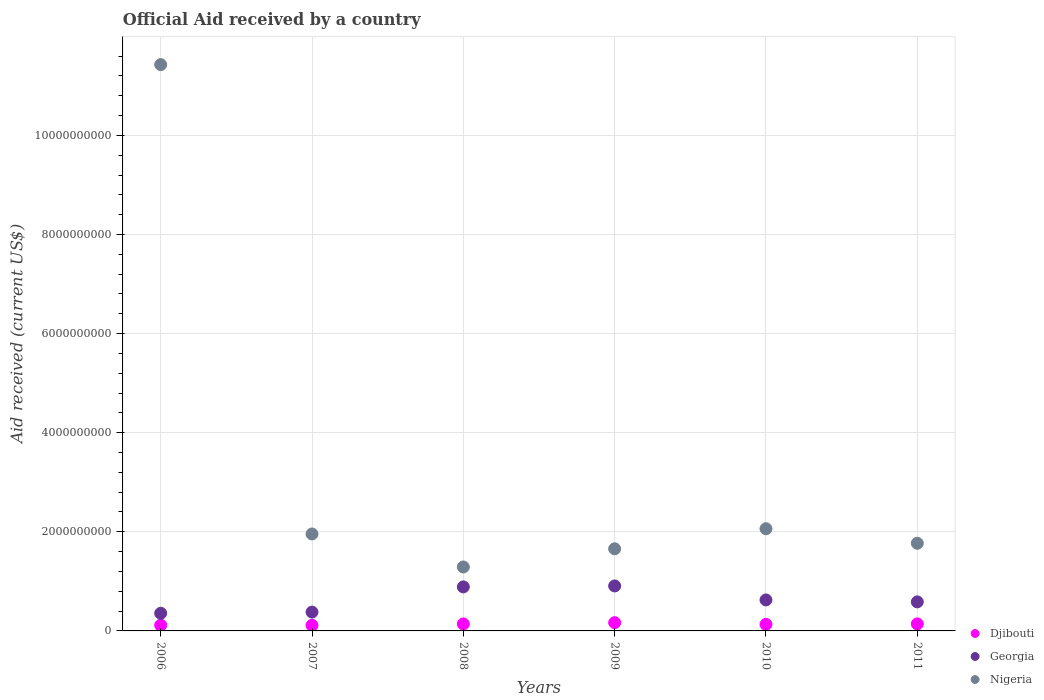How many different coloured dotlines are there?
Offer a terse response. 3. What is the net official aid received in Nigeria in 2008?
Ensure brevity in your answer.  1.29e+09. Across all years, what is the maximum net official aid received in Nigeria?
Offer a very short reply. 1.14e+1. Across all years, what is the minimum net official aid received in Georgia?
Your answer should be very brief. 3.56e+08. In which year was the net official aid received in Nigeria maximum?
Ensure brevity in your answer.  2006. What is the total net official aid received in Djibouti in the graph?
Provide a short and direct response. 8.09e+08. What is the difference between the net official aid received in Djibouti in 2006 and that in 2009?
Offer a terse response. -5.15e+07. What is the difference between the net official aid received in Djibouti in 2008 and the net official aid received in Nigeria in 2009?
Offer a very short reply. -1.52e+09. What is the average net official aid received in Nigeria per year?
Give a very brief answer. 3.36e+09. In the year 2008, what is the difference between the net official aid received in Nigeria and net official aid received in Georgia?
Provide a succinct answer. 4.02e+08. What is the ratio of the net official aid received in Georgia in 2007 to that in 2008?
Your response must be concise. 0.43. Is the net official aid received in Nigeria in 2010 less than that in 2011?
Ensure brevity in your answer.  No. Is the difference between the net official aid received in Nigeria in 2009 and 2010 greater than the difference between the net official aid received in Georgia in 2009 and 2010?
Your answer should be very brief. No. What is the difference between the highest and the second highest net official aid received in Nigeria?
Your answer should be compact. 9.37e+09. What is the difference between the highest and the lowest net official aid received in Georgia?
Offer a terse response. 5.52e+08. In how many years, is the net official aid received in Nigeria greater than the average net official aid received in Nigeria taken over all years?
Provide a succinct answer. 1. Is the sum of the net official aid received in Djibouti in 2008 and 2011 greater than the maximum net official aid received in Nigeria across all years?
Keep it short and to the point. No. Does the net official aid received in Georgia monotonically increase over the years?
Your answer should be compact. No. How many dotlines are there?
Ensure brevity in your answer.  3. Are the values on the major ticks of Y-axis written in scientific E-notation?
Offer a very short reply. No. Does the graph contain any zero values?
Your answer should be compact. No. How many legend labels are there?
Give a very brief answer. 3. What is the title of the graph?
Ensure brevity in your answer.  Official Aid received by a country. What is the label or title of the Y-axis?
Give a very brief answer. Aid received (current US$). What is the Aid received (current US$) in Djibouti in 2006?
Give a very brief answer. 1.15e+08. What is the Aid received (current US$) in Georgia in 2006?
Your answer should be very brief. 3.56e+08. What is the Aid received (current US$) of Nigeria in 2006?
Ensure brevity in your answer.  1.14e+1. What is the Aid received (current US$) of Djibouti in 2007?
Offer a very short reply. 1.13e+08. What is the Aid received (current US$) of Georgia in 2007?
Give a very brief answer. 3.80e+08. What is the Aid received (current US$) in Nigeria in 2007?
Make the answer very short. 1.96e+09. What is the Aid received (current US$) in Djibouti in 2008?
Offer a terse response. 1.41e+08. What is the Aid received (current US$) in Georgia in 2008?
Offer a very short reply. 8.88e+08. What is the Aid received (current US$) in Nigeria in 2008?
Your answer should be very brief. 1.29e+09. What is the Aid received (current US$) of Djibouti in 2009?
Your answer should be very brief. 1.67e+08. What is the Aid received (current US$) of Georgia in 2009?
Offer a very short reply. 9.08e+08. What is the Aid received (current US$) in Nigeria in 2009?
Your answer should be compact. 1.66e+09. What is the Aid received (current US$) of Djibouti in 2010?
Offer a very short reply. 1.32e+08. What is the Aid received (current US$) in Georgia in 2010?
Keep it short and to the point. 6.26e+08. What is the Aid received (current US$) in Nigeria in 2010?
Ensure brevity in your answer.  2.06e+09. What is the Aid received (current US$) in Djibouti in 2011?
Your answer should be very brief. 1.42e+08. What is the Aid received (current US$) of Georgia in 2011?
Ensure brevity in your answer.  5.86e+08. What is the Aid received (current US$) in Nigeria in 2011?
Offer a terse response. 1.77e+09. Across all years, what is the maximum Aid received (current US$) in Djibouti?
Give a very brief answer. 1.67e+08. Across all years, what is the maximum Aid received (current US$) in Georgia?
Give a very brief answer. 9.08e+08. Across all years, what is the maximum Aid received (current US$) of Nigeria?
Provide a succinct answer. 1.14e+1. Across all years, what is the minimum Aid received (current US$) in Djibouti?
Provide a succinct answer. 1.13e+08. Across all years, what is the minimum Aid received (current US$) of Georgia?
Keep it short and to the point. 3.56e+08. Across all years, what is the minimum Aid received (current US$) of Nigeria?
Make the answer very short. 1.29e+09. What is the total Aid received (current US$) of Djibouti in the graph?
Give a very brief answer. 8.09e+08. What is the total Aid received (current US$) of Georgia in the graph?
Your answer should be compact. 3.74e+09. What is the total Aid received (current US$) of Nigeria in the graph?
Provide a succinct answer. 2.02e+1. What is the difference between the Aid received (current US$) in Djibouti in 2006 and that in 2007?
Your answer should be very brief. 2.64e+06. What is the difference between the Aid received (current US$) of Georgia in 2006 and that in 2007?
Offer a terse response. -2.35e+07. What is the difference between the Aid received (current US$) in Nigeria in 2006 and that in 2007?
Offer a terse response. 9.47e+09. What is the difference between the Aid received (current US$) in Djibouti in 2006 and that in 2008?
Your response must be concise. -2.56e+07. What is the difference between the Aid received (current US$) in Georgia in 2006 and that in 2008?
Provide a short and direct response. -5.32e+08. What is the difference between the Aid received (current US$) of Nigeria in 2006 and that in 2008?
Make the answer very short. 1.01e+1. What is the difference between the Aid received (current US$) in Djibouti in 2006 and that in 2009?
Ensure brevity in your answer.  -5.15e+07. What is the difference between the Aid received (current US$) of Georgia in 2006 and that in 2009?
Give a very brief answer. -5.52e+08. What is the difference between the Aid received (current US$) in Nigeria in 2006 and that in 2009?
Keep it short and to the point. 9.77e+09. What is the difference between the Aid received (current US$) in Djibouti in 2006 and that in 2010?
Give a very brief answer. -1.70e+07. What is the difference between the Aid received (current US$) in Georgia in 2006 and that in 2010?
Ensure brevity in your answer.  -2.69e+08. What is the difference between the Aid received (current US$) in Nigeria in 2006 and that in 2010?
Ensure brevity in your answer.  9.37e+09. What is the difference between the Aid received (current US$) in Djibouti in 2006 and that in 2011?
Make the answer very short. -2.65e+07. What is the difference between the Aid received (current US$) of Georgia in 2006 and that in 2011?
Give a very brief answer. -2.30e+08. What is the difference between the Aid received (current US$) in Nigeria in 2006 and that in 2011?
Offer a terse response. 9.66e+09. What is the difference between the Aid received (current US$) of Djibouti in 2007 and that in 2008?
Provide a short and direct response. -2.82e+07. What is the difference between the Aid received (current US$) of Georgia in 2007 and that in 2008?
Provide a short and direct response. -5.09e+08. What is the difference between the Aid received (current US$) in Nigeria in 2007 and that in 2008?
Ensure brevity in your answer.  6.66e+08. What is the difference between the Aid received (current US$) of Djibouti in 2007 and that in 2009?
Your response must be concise. -5.41e+07. What is the difference between the Aid received (current US$) of Georgia in 2007 and that in 2009?
Your answer should be compact. -5.28e+08. What is the difference between the Aid received (current US$) of Nigeria in 2007 and that in 2009?
Give a very brief answer. 2.99e+08. What is the difference between the Aid received (current US$) in Djibouti in 2007 and that in 2010?
Your answer should be compact. -1.96e+07. What is the difference between the Aid received (current US$) in Georgia in 2007 and that in 2010?
Ensure brevity in your answer.  -2.46e+08. What is the difference between the Aid received (current US$) in Nigeria in 2007 and that in 2010?
Ensure brevity in your answer.  -1.06e+08. What is the difference between the Aid received (current US$) of Djibouti in 2007 and that in 2011?
Give a very brief answer. -2.91e+07. What is the difference between the Aid received (current US$) in Georgia in 2007 and that in 2011?
Your answer should be compact. -2.06e+08. What is the difference between the Aid received (current US$) of Nigeria in 2007 and that in 2011?
Keep it short and to the point. 1.88e+08. What is the difference between the Aid received (current US$) in Djibouti in 2008 and that in 2009?
Keep it short and to the point. -2.59e+07. What is the difference between the Aid received (current US$) in Georgia in 2008 and that in 2009?
Your response must be concise. -1.93e+07. What is the difference between the Aid received (current US$) in Nigeria in 2008 and that in 2009?
Keep it short and to the point. -3.67e+08. What is the difference between the Aid received (current US$) of Djibouti in 2008 and that in 2010?
Make the answer very short. 8.58e+06. What is the difference between the Aid received (current US$) in Georgia in 2008 and that in 2010?
Ensure brevity in your answer.  2.63e+08. What is the difference between the Aid received (current US$) in Nigeria in 2008 and that in 2010?
Keep it short and to the point. -7.72e+08. What is the difference between the Aid received (current US$) in Djibouti in 2008 and that in 2011?
Your response must be concise. -9.30e+05. What is the difference between the Aid received (current US$) in Georgia in 2008 and that in 2011?
Your answer should be very brief. 3.02e+08. What is the difference between the Aid received (current US$) in Nigeria in 2008 and that in 2011?
Offer a terse response. -4.78e+08. What is the difference between the Aid received (current US$) in Djibouti in 2009 and that in 2010?
Offer a very short reply. 3.45e+07. What is the difference between the Aid received (current US$) of Georgia in 2009 and that in 2010?
Offer a very short reply. 2.82e+08. What is the difference between the Aid received (current US$) of Nigeria in 2009 and that in 2010?
Your response must be concise. -4.05e+08. What is the difference between the Aid received (current US$) in Djibouti in 2009 and that in 2011?
Your answer should be very brief. 2.50e+07. What is the difference between the Aid received (current US$) of Georgia in 2009 and that in 2011?
Make the answer very short. 3.22e+08. What is the difference between the Aid received (current US$) in Nigeria in 2009 and that in 2011?
Offer a very short reply. -1.11e+08. What is the difference between the Aid received (current US$) in Djibouti in 2010 and that in 2011?
Offer a very short reply. -9.51e+06. What is the difference between the Aid received (current US$) in Georgia in 2010 and that in 2011?
Your answer should be compact. 3.95e+07. What is the difference between the Aid received (current US$) of Nigeria in 2010 and that in 2011?
Your response must be concise. 2.93e+08. What is the difference between the Aid received (current US$) in Djibouti in 2006 and the Aid received (current US$) in Georgia in 2007?
Give a very brief answer. -2.64e+08. What is the difference between the Aid received (current US$) of Djibouti in 2006 and the Aid received (current US$) of Nigeria in 2007?
Offer a terse response. -1.84e+09. What is the difference between the Aid received (current US$) in Georgia in 2006 and the Aid received (current US$) in Nigeria in 2007?
Your answer should be compact. -1.60e+09. What is the difference between the Aid received (current US$) in Djibouti in 2006 and the Aid received (current US$) in Georgia in 2008?
Ensure brevity in your answer.  -7.73e+08. What is the difference between the Aid received (current US$) in Djibouti in 2006 and the Aid received (current US$) in Nigeria in 2008?
Provide a succinct answer. -1.17e+09. What is the difference between the Aid received (current US$) in Georgia in 2006 and the Aid received (current US$) in Nigeria in 2008?
Provide a short and direct response. -9.34e+08. What is the difference between the Aid received (current US$) in Djibouti in 2006 and the Aid received (current US$) in Georgia in 2009?
Your response must be concise. -7.92e+08. What is the difference between the Aid received (current US$) of Djibouti in 2006 and the Aid received (current US$) of Nigeria in 2009?
Give a very brief answer. -1.54e+09. What is the difference between the Aid received (current US$) in Georgia in 2006 and the Aid received (current US$) in Nigeria in 2009?
Ensure brevity in your answer.  -1.30e+09. What is the difference between the Aid received (current US$) in Djibouti in 2006 and the Aid received (current US$) in Georgia in 2010?
Offer a terse response. -5.10e+08. What is the difference between the Aid received (current US$) of Djibouti in 2006 and the Aid received (current US$) of Nigeria in 2010?
Your answer should be compact. -1.95e+09. What is the difference between the Aid received (current US$) of Georgia in 2006 and the Aid received (current US$) of Nigeria in 2010?
Your response must be concise. -1.71e+09. What is the difference between the Aid received (current US$) of Djibouti in 2006 and the Aid received (current US$) of Georgia in 2011?
Provide a succinct answer. -4.71e+08. What is the difference between the Aid received (current US$) in Djibouti in 2006 and the Aid received (current US$) in Nigeria in 2011?
Offer a very short reply. -1.65e+09. What is the difference between the Aid received (current US$) of Georgia in 2006 and the Aid received (current US$) of Nigeria in 2011?
Give a very brief answer. -1.41e+09. What is the difference between the Aid received (current US$) of Djibouti in 2007 and the Aid received (current US$) of Georgia in 2008?
Offer a terse response. -7.76e+08. What is the difference between the Aid received (current US$) of Djibouti in 2007 and the Aid received (current US$) of Nigeria in 2008?
Your answer should be very brief. -1.18e+09. What is the difference between the Aid received (current US$) of Georgia in 2007 and the Aid received (current US$) of Nigeria in 2008?
Ensure brevity in your answer.  -9.11e+08. What is the difference between the Aid received (current US$) in Djibouti in 2007 and the Aid received (current US$) in Georgia in 2009?
Offer a very short reply. -7.95e+08. What is the difference between the Aid received (current US$) of Djibouti in 2007 and the Aid received (current US$) of Nigeria in 2009?
Give a very brief answer. -1.54e+09. What is the difference between the Aid received (current US$) in Georgia in 2007 and the Aid received (current US$) in Nigeria in 2009?
Offer a very short reply. -1.28e+09. What is the difference between the Aid received (current US$) in Djibouti in 2007 and the Aid received (current US$) in Georgia in 2010?
Provide a short and direct response. -5.13e+08. What is the difference between the Aid received (current US$) of Djibouti in 2007 and the Aid received (current US$) of Nigeria in 2010?
Your response must be concise. -1.95e+09. What is the difference between the Aid received (current US$) in Georgia in 2007 and the Aid received (current US$) in Nigeria in 2010?
Your answer should be very brief. -1.68e+09. What is the difference between the Aid received (current US$) of Djibouti in 2007 and the Aid received (current US$) of Georgia in 2011?
Your answer should be compact. -4.73e+08. What is the difference between the Aid received (current US$) of Djibouti in 2007 and the Aid received (current US$) of Nigeria in 2011?
Offer a very short reply. -1.66e+09. What is the difference between the Aid received (current US$) of Georgia in 2007 and the Aid received (current US$) of Nigeria in 2011?
Your response must be concise. -1.39e+09. What is the difference between the Aid received (current US$) of Djibouti in 2008 and the Aid received (current US$) of Georgia in 2009?
Ensure brevity in your answer.  -7.67e+08. What is the difference between the Aid received (current US$) in Djibouti in 2008 and the Aid received (current US$) in Nigeria in 2009?
Give a very brief answer. -1.52e+09. What is the difference between the Aid received (current US$) in Georgia in 2008 and the Aid received (current US$) in Nigeria in 2009?
Make the answer very short. -7.69e+08. What is the difference between the Aid received (current US$) of Djibouti in 2008 and the Aid received (current US$) of Georgia in 2010?
Your answer should be compact. -4.85e+08. What is the difference between the Aid received (current US$) of Djibouti in 2008 and the Aid received (current US$) of Nigeria in 2010?
Provide a succinct answer. -1.92e+09. What is the difference between the Aid received (current US$) in Georgia in 2008 and the Aid received (current US$) in Nigeria in 2010?
Provide a short and direct response. -1.17e+09. What is the difference between the Aid received (current US$) in Djibouti in 2008 and the Aid received (current US$) in Georgia in 2011?
Give a very brief answer. -4.45e+08. What is the difference between the Aid received (current US$) in Djibouti in 2008 and the Aid received (current US$) in Nigeria in 2011?
Your answer should be very brief. -1.63e+09. What is the difference between the Aid received (current US$) of Georgia in 2008 and the Aid received (current US$) of Nigeria in 2011?
Provide a short and direct response. -8.80e+08. What is the difference between the Aid received (current US$) of Djibouti in 2009 and the Aid received (current US$) of Georgia in 2010?
Keep it short and to the point. -4.59e+08. What is the difference between the Aid received (current US$) of Djibouti in 2009 and the Aid received (current US$) of Nigeria in 2010?
Offer a very short reply. -1.90e+09. What is the difference between the Aid received (current US$) in Georgia in 2009 and the Aid received (current US$) in Nigeria in 2010?
Ensure brevity in your answer.  -1.15e+09. What is the difference between the Aid received (current US$) in Djibouti in 2009 and the Aid received (current US$) in Georgia in 2011?
Offer a terse response. -4.19e+08. What is the difference between the Aid received (current US$) of Djibouti in 2009 and the Aid received (current US$) of Nigeria in 2011?
Ensure brevity in your answer.  -1.60e+09. What is the difference between the Aid received (current US$) of Georgia in 2009 and the Aid received (current US$) of Nigeria in 2011?
Keep it short and to the point. -8.61e+08. What is the difference between the Aid received (current US$) of Djibouti in 2010 and the Aid received (current US$) of Georgia in 2011?
Ensure brevity in your answer.  -4.54e+08. What is the difference between the Aid received (current US$) in Djibouti in 2010 and the Aid received (current US$) in Nigeria in 2011?
Give a very brief answer. -1.64e+09. What is the difference between the Aid received (current US$) of Georgia in 2010 and the Aid received (current US$) of Nigeria in 2011?
Give a very brief answer. -1.14e+09. What is the average Aid received (current US$) in Djibouti per year?
Provide a short and direct response. 1.35e+08. What is the average Aid received (current US$) in Georgia per year?
Keep it short and to the point. 6.24e+08. What is the average Aid received (current US$) in Nigeria per year?
Your answer should be very brief. 3.36e+09. In the year 2006, what is the difference between the Aid received (current US$) of Djibouti and Aid received (current US$) of Georgia?
Give a very brief answer. -2.41e+08. In the year 2006, what is the difference between the Aid received (current US$) in Djibouti and Aid received (current US$) in Nigeria?
Provide a succinct answer. -1.13e+1. In the year 2006, what is the difference between the Aid received (current US$) in Georgia and Aid received (current US$) in Nigeria?
Offer a terse response. -1.11e+1. In the year 2007, what is the difference between the Aid received (current US$) of Djibouti and Aid received (current US$) of Georgia?
Your answer should be very brief. -2.67e+08. In the year 2007, what is the difference between the Aid received (current US$) of Djibouti and Aid received (current US$) of Nigeria?
Provide a short and direct response. -1.84e+09. In the year 2007, what is the difference between the Aid received (current US$) of Georgia and Aid received (current US$) of Nigeria?
Offer a terse response. -1.58e+09. In the year 2008, what is the difference between the Aid received (current US$) in Djibouti and Aid received (current US$) in Georgia?
Your answer should be very brief. -7.48e+08. In the year 2008, what is the difference between the Aid received (current US$) in Djibouti and Aid received (current US$) in Nigeria?
Your response must be concise. -1.15e+09. In the year 2008, what is the difference between the Aid received (current US$) in Georgia and Aid received (current US$) in Nigeria?
Make the answer very short. -4.02e+08. In the year 2009, what is the difference between the Aid received (current US$) in Djibouti and Aid received (current US$) in Georgia?
Make the answer very short. -7.41e+08. In the year 2009, what is the difference between the Aid received (current US$) in Djibouti and Aid received (current US$) in Nigeria?
Make the answer very short. -1.49e+09. In the year 2009, what is the difference between the Aid received (current US$) of Georgia and Aid received (current US$) of Nigeria?
Offer a very short reply. -7.49e+08. In the year 2010, what is the difference between the Aid received (current US$) of Djibouti and Aid received (current US$) of Georgia?
Your answer should be very brief. -4.93e+08. In the year 2010, what is the difference between the Aid received (current US$) in Djibouti and Aid received (current US$) in Nigeria?
Your answer should be compact. -1.93e+09. In the year 2010, what is the difference between the Aid received (current US$) in Georgia and Aid received (current US$) in Nigeria?
Your response must be concise. -1.44e+09. In the year 2011, what is the difference between the Aid received (current US$) in Djibouti and Aid received (current US$) in Georgia?
Your response must be concise. -4.44e+08. In the year 2011, what is the difference between the Aid received (current US$) of Djibouti and Aid received (current US$) of Nigeria?
Keep it short and to the point. -1.63e+09. In the year 2011, what is the difference between the Aid received (current US$) in Georgia and Aid received (current US$) in Nigeria?
Provide a short and direct response. -1.18e+09. What is the ratio of the Aid received (current US$) in Djibouti in 2006 to that in 2007?
Ensure brevity in your answer.  1.02. What is the ratio of the Aid received (current US$) in Georgia in 2006 to that in 2007?
Your response must be concise. 0.94. What is the ratio of the Aid received (current US$) in Nigeria in 2006 to that in 2007?
Offer a very short reply. 5.84. What is the ratio of the Aid received (current US$) in Djibouti in 2006 to that in 2008?
Your answer should be compact. 0.82. What is the ratio of the Aid received (current US$) in Georgia in 2006 to that in 2008?
Keep it short and to the point. 0.4. What is the ratio of the Aid received (current US$) of Nigeria in 2006 to that in 2008?
Your answer should be very brief. 8.86. What is the ratio of the Aid received (current US$) of Djibouti in 2006 to that in 2009?
Make the answer very short. 0.69. What is the ratio of the Aid received (current US$) in Georgia in 2006 to that in 2009?
Your answer should be compact. 0.39. What is the ratio of the Aid received (current US$) of Nigeria in 2006 to that in 2009?
Give a very brief answer. 6.9. What is the ratio of the Aid received (current US$) of Djibouti in 2006 to that in 2010?
Offer a terse response. 0.87. What is the ratio of the Aid received (current US$) of Georgia in 2006 to that in 2010?
Offer a terse response. 0.57. What is the ratio of the Aid received (current US$) in Nigeria in 2006 to that in 2010?
Make the answer very short. 5.54. What is the ratio of the Aid received (current US$) of Djibouti in 2006 to that in 2011?
Keep it short and to the point. 0.81. What is the ratio of the Aid received (current US$) in Georgia in 2006 to that in 2011?
Give a very brief answer. 0.61. What is the ratio of the Aid received (current US$) in Nigeria in 2006 to that in 2011?
Ensure brevity in your answer.  6.46. What is the ratio of the Aid received (current US$) of Djibouti in 2007 to that in 2008?
Provide a short and direct response. 0.8. What is the ratio of the Aid received (current US$) of Georgia in 2007 to that in 2008?
Your answer should be very brief. 0.43. What is the ratio of the Aid received (current US$) in Nigeria in 2007 to that in 2008?
Give a very brief answer. 1.52. What is the ratio of the Aid received (current US$) in Djibouti in 2007 to that in 2009?
Offer a terse response. 0.68. What is the ratio of the Aid received (current US$) of Georgia in 2007 to that in 2009?
Provide a short and direct response. 0.42. What is the ratio of the Aid received (current US$) of Nigeria in 2007 to that in 2009?
Your response must be concise. 1.18. What is the ratio of the Aid received (current US$) of Djibouti in 2007 to that in 2010?
Provide a succinct answer. 0.85. What is the ratio of the Aid received (current US$) in Georgia in 2007 to that in 2010?
Offer a terse response. 0.61. What is the ratio of the Aid received (current US$) in Nigeria in 2007 to that in 2010?
Provide a succinct answer. 0.95. What is the ratio of the Aid received (current US$) in Djibouti in 2007 to that in 2011?
Your answer should be very brief. 0.79. What is the ratio of the Aid received (current US$) in Georgia in 2007 to that in 2011?
Your answer should be very brief. 0.65. What is the ratio of the Aid received (current US$) of Nigeria in 2007 to that in 2011?
Your response must be concise. 1.11. What is the ratio of the Aid received (current US$) in Djibouti in 2008 to that in 2009?
Your answer should be compact. 0.84. What is the ratio of the Aid received (current US$) of Georgia in 2008 to that in 2009?
Give a very brief answer. 0.98. What is the ratio of the Aid received (current US$) in Nigeria in 2008 to that in 2009?
Give a very brief answer. 0.78. What is the ratio of the Aid received (current US$) in Djibouti in 2008 to that in 2010?
Provide a succinct answer. 1.06. What is the ratio of the Aid received (current US$) of Georgia in 2008 to that in 2010?
Your answer should be very brief. 1.42. What is the ratio of the Aid received (current US$) of Nigeria in 2008 to that in 2010?
Provide a succinct answer. 0.63. What is the ratio of the Aid received (current US$) of Georgia in 2008 to that in 2011?
Give a very brief answer. 1.52. What is the ratio of the Aid received (current US$) in Nigeria in 2008 to that in 2011?
Provide a succinct answer. 0.73. What is the ratio of the Aid received (current US$) in Djibouti in 2009 to that in 2010?
Provide a short and direct response. 1.26. What is the ratio of the Aid received (current US$) in Georgia in 2009 to that in 2010?
Keep it short and to the point. 1.45. What is the ratio of the Aid received (current US$) of Nigeria in 2009 to that in 2010?
Give a very brief answer. 0.8. What is the ratio of the Aid received (current US$) of Djibouti in 2009 to that in 2011?
Your answer should be compact. 1.18. What is the ratio of the Aid received (current US$) in Georgia in 2009 to that in 2011?
Your answer should be compact. 1.55. What is the ratio of the Aid received (current US$) in Nigeria in 2009 to that in 2011?
Offer a terse response. 0.94. What is the ratio of the Aid received (current US$) of Djibouti in 2010 to that in 2011?
Provide a succinct answer. 0.93. What is the ratio of the Aid received (current US$) of Georgia in 2010 to that in 2011?
Your answer should be very brief. 1.07. What is the ratio of the Aid received (current US$) in Nigeria in 2010 to that in 2011?
Offer a terse response. 1.17. What is the difference between the highest and the second highest Aid received (current US$) of Djibouti?
Make the answer very short. 2.50e+07. What is the difference between the highest and the second highest Aid received (current US$) of Georgia?
Give a very brief answer. 1.93e+07. What is the difference between the highest and the second highest Aid received (current US$) of Nigeria?
Offer a very short reply. 9.37e+09. What is the difference between the highest and the lowest Aid received (current US$) of Djibouti?
Your answer should be very brief. 5.41e+07. What is the difference between the highest and the lowest Aid received (current US$) in Georgia?
Make the answer very short. 5.52e+08. What is the difference between the highest and the lowest Aid received (current US$) in Nigeria?
Make the answer very short. 1.01e+1. 